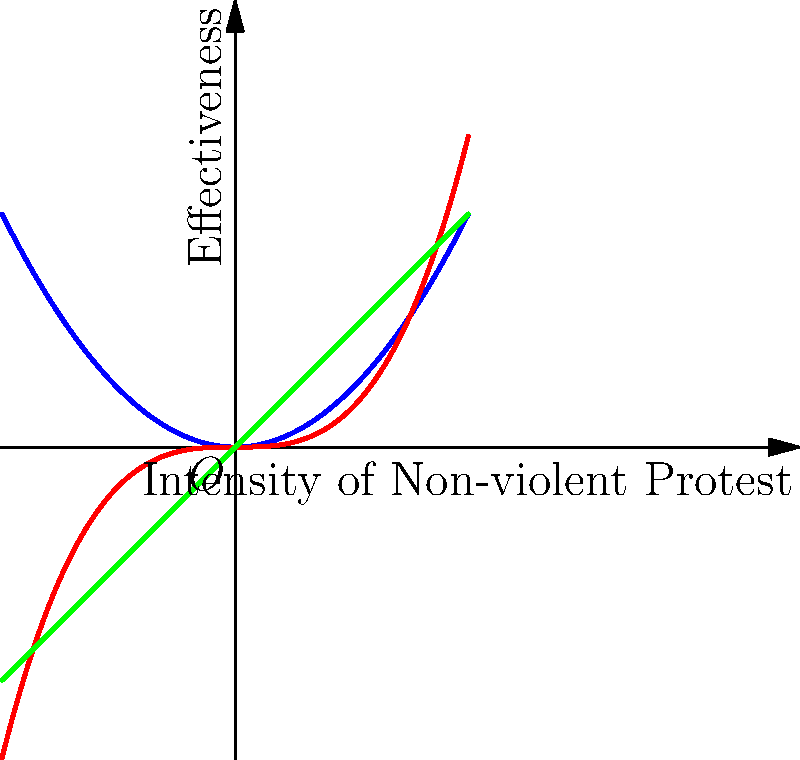Consider the topological space of non-violent protest strategies represented by the curves $S_1$, $S_2$, and $S_3$ in the graph. Which pair of strategies are homeomorphic, and how might this inform the selection of effective non-violent protest methods? To determine which pair of strategies are homeomorphic, we need to analyze their topological properties:

1. Continuity: All three curves are continuous functions over the given domain.

2. Bijectivity: 
   - $S_1$ (blue): $f_1(x) = 0.5x^2$ is not bijective as it's not one-to-one (each y-value corresponds to two x-values, except at the origin).
   - $S_2$ (red): $f_2(x) = x^3/3$ is bijective as it's both one-to-one and onto.
   - $S_3$ (green): $f_3(x) = x$ is bijective as it's both one-to-one and onto.

3. Continuous inverse: Both $S_2$ and $S_3$ have continuous inverses.

Therefore, $S_2$ and $S_3$ are homeomorphic to each other, but not to $S_1$.

This homeomorphism suggests that strategies represented by $S_2$ and $S_3$ are topologically equivalent, meaning they can be continuously deformed into each other without breaking or gluing. In the context of non-violent protest:

- $S_3$ represents a linear relationship between protest intensity and effectiveness.
- $S_2$ shows a slower initial increase in effectiveness, followed by a more rapid increase as intensity grows.

The homeomorphism between these strategies implies that a peace advocate could potentially transition between these approaches smoothly, adapting the protest strategy based on the specific context or response from authorities, while maintaining the overall structure of the non-violent approach.
Answer: $S_2$ and $S_3$ are homeomorphic, allowing flexible adaptation between gradual and linear protest strategies while maintaining non-violent principles. 